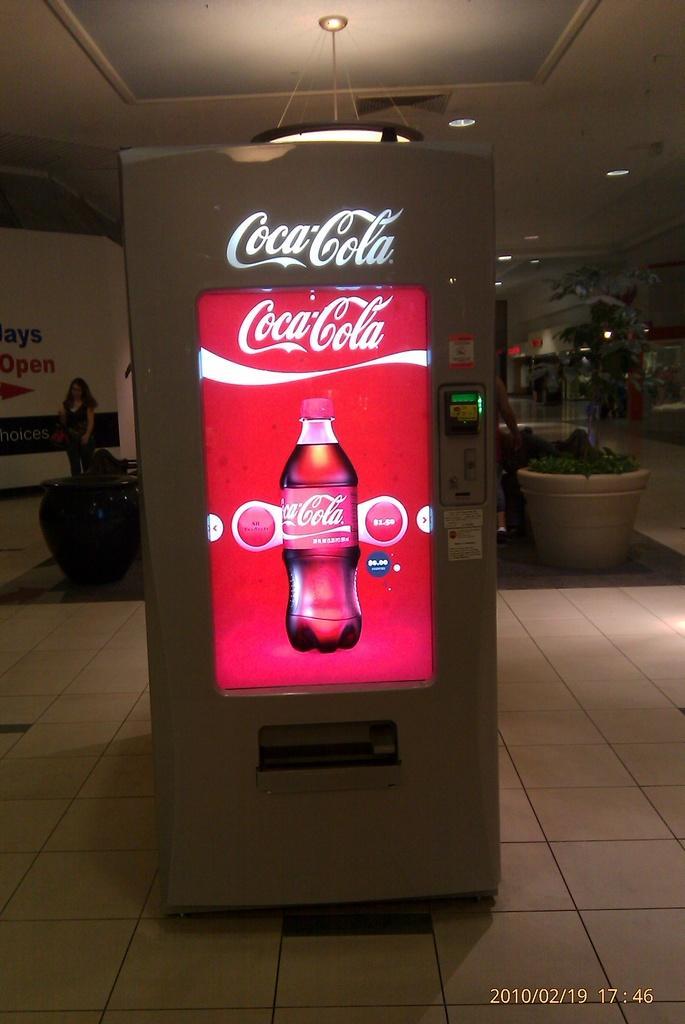Describe this image in one or two sentences. In this image I see a vending machine in front and there is a screen on it, I can also see that on the screen there is a bottle on which it is written Coca Cola and it is written over here also. In the background I see few pots and plants in it and I see the lights over here. 